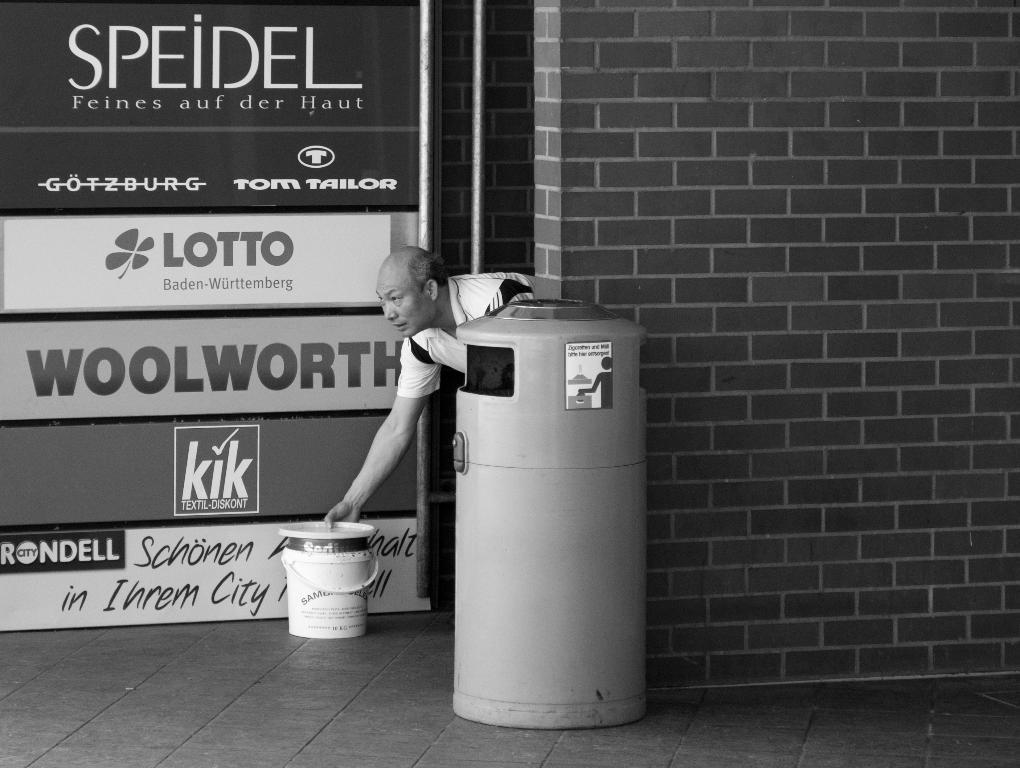<image>
Share a concise interpretation of the image provided. Advertisements for Woolworth and kik and Lotto and Speidel. 